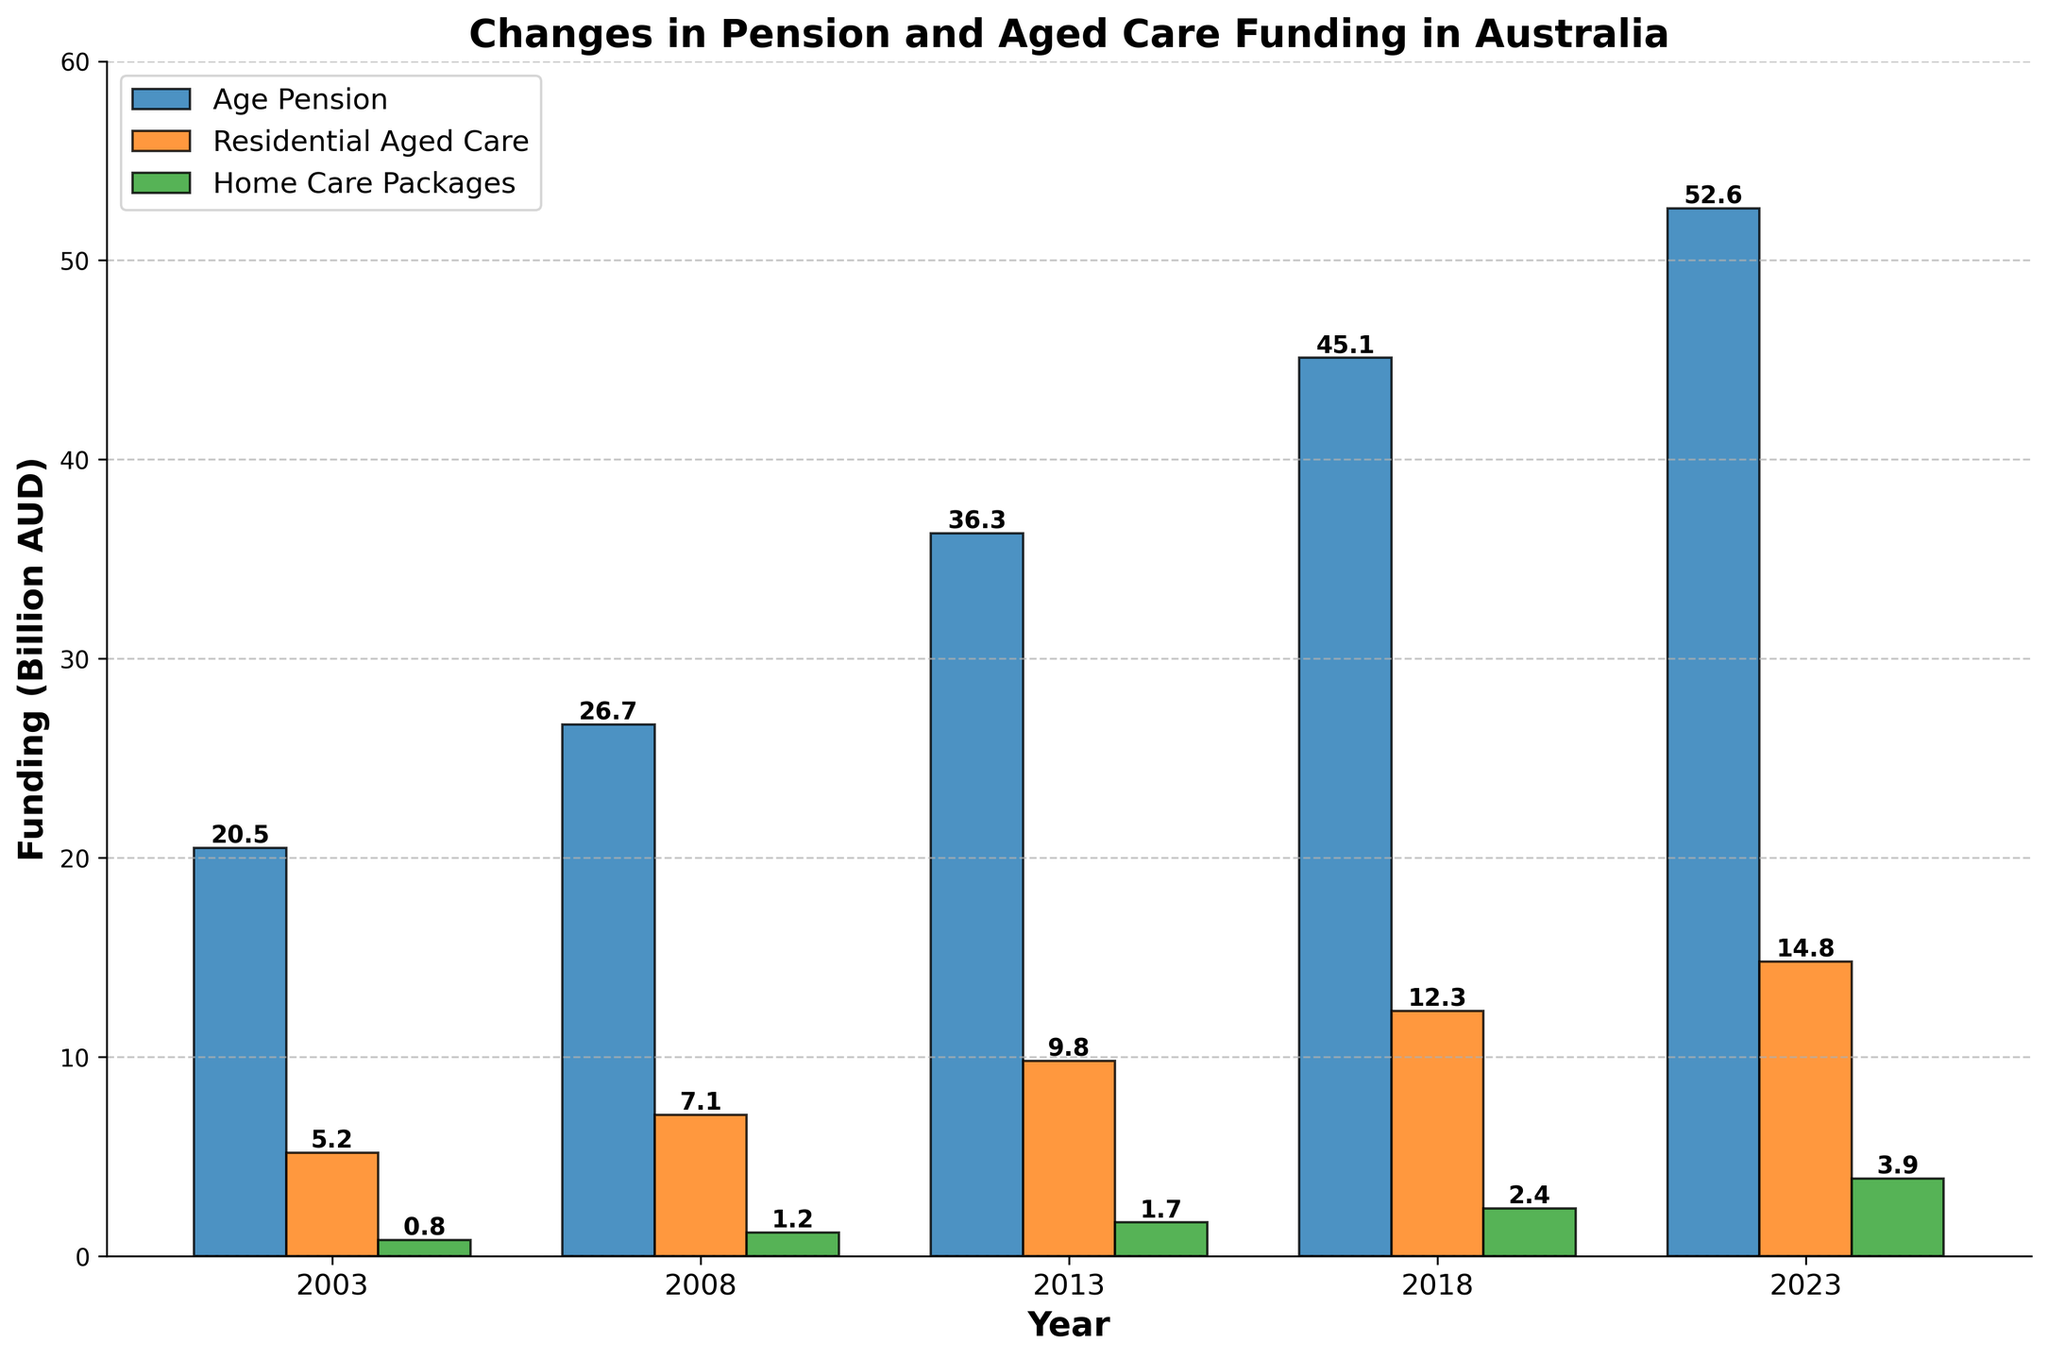What is the total funding for Age Pension across all the years? Sum the values for Age Pension from each year: 20.5 (2003) + 26.7 (2008) + 36.3 (2013) + 45.1 (2018) + 52.6 (2023). Adding these amounts results in 181.2 billion AUD
Answer: 181.2 billion AUD Which category had the smallest funding in 2008? Look at the bars for the year 2008 and compare the heights. Home Care Packages had the smallest bar indicating the smallest funding.
Answer: Home Care Packages By how much did the funding for Residential Aged Care increase from 2003 to 2023? Subtract the 2003 value for Residential Aged Care from the 2023 value: 14.8 billion AUD (2023) - 5.2 billion AUD (2003). This results in an increase of 9.6 billion AUD
Answer: 9.6 billion AUD What was the average funding for Home Care Packages over the 20 years? Add the funding values for Home Care Packages: 0.8 (2003) + 1.2 (2008) + 1.7 (2013) + 2.4 (2018) + 3.9 (2023). The total is 10. Multiply by the number of years (5) so the average is 10/5 = 2 billion AUD
Answer: 2 billion AUD Which year had the highest total funding across all categories? Sum the funding for each category for each year, then compare the totals. 2003: 20.5 + 5.2 + 0.8 = 26.5, 2008: 26.7 + 7.1 + 1.2 = 35, 2013: 36.3 + 9.8 + 1.7 = 47.8, 2018: 45.1 + 12.3 + 2.4 = 59.8, 2023: 52.6 + 14.8 + 3.9 = 71.3, so the highest total is in 2023
Answer: 2023 